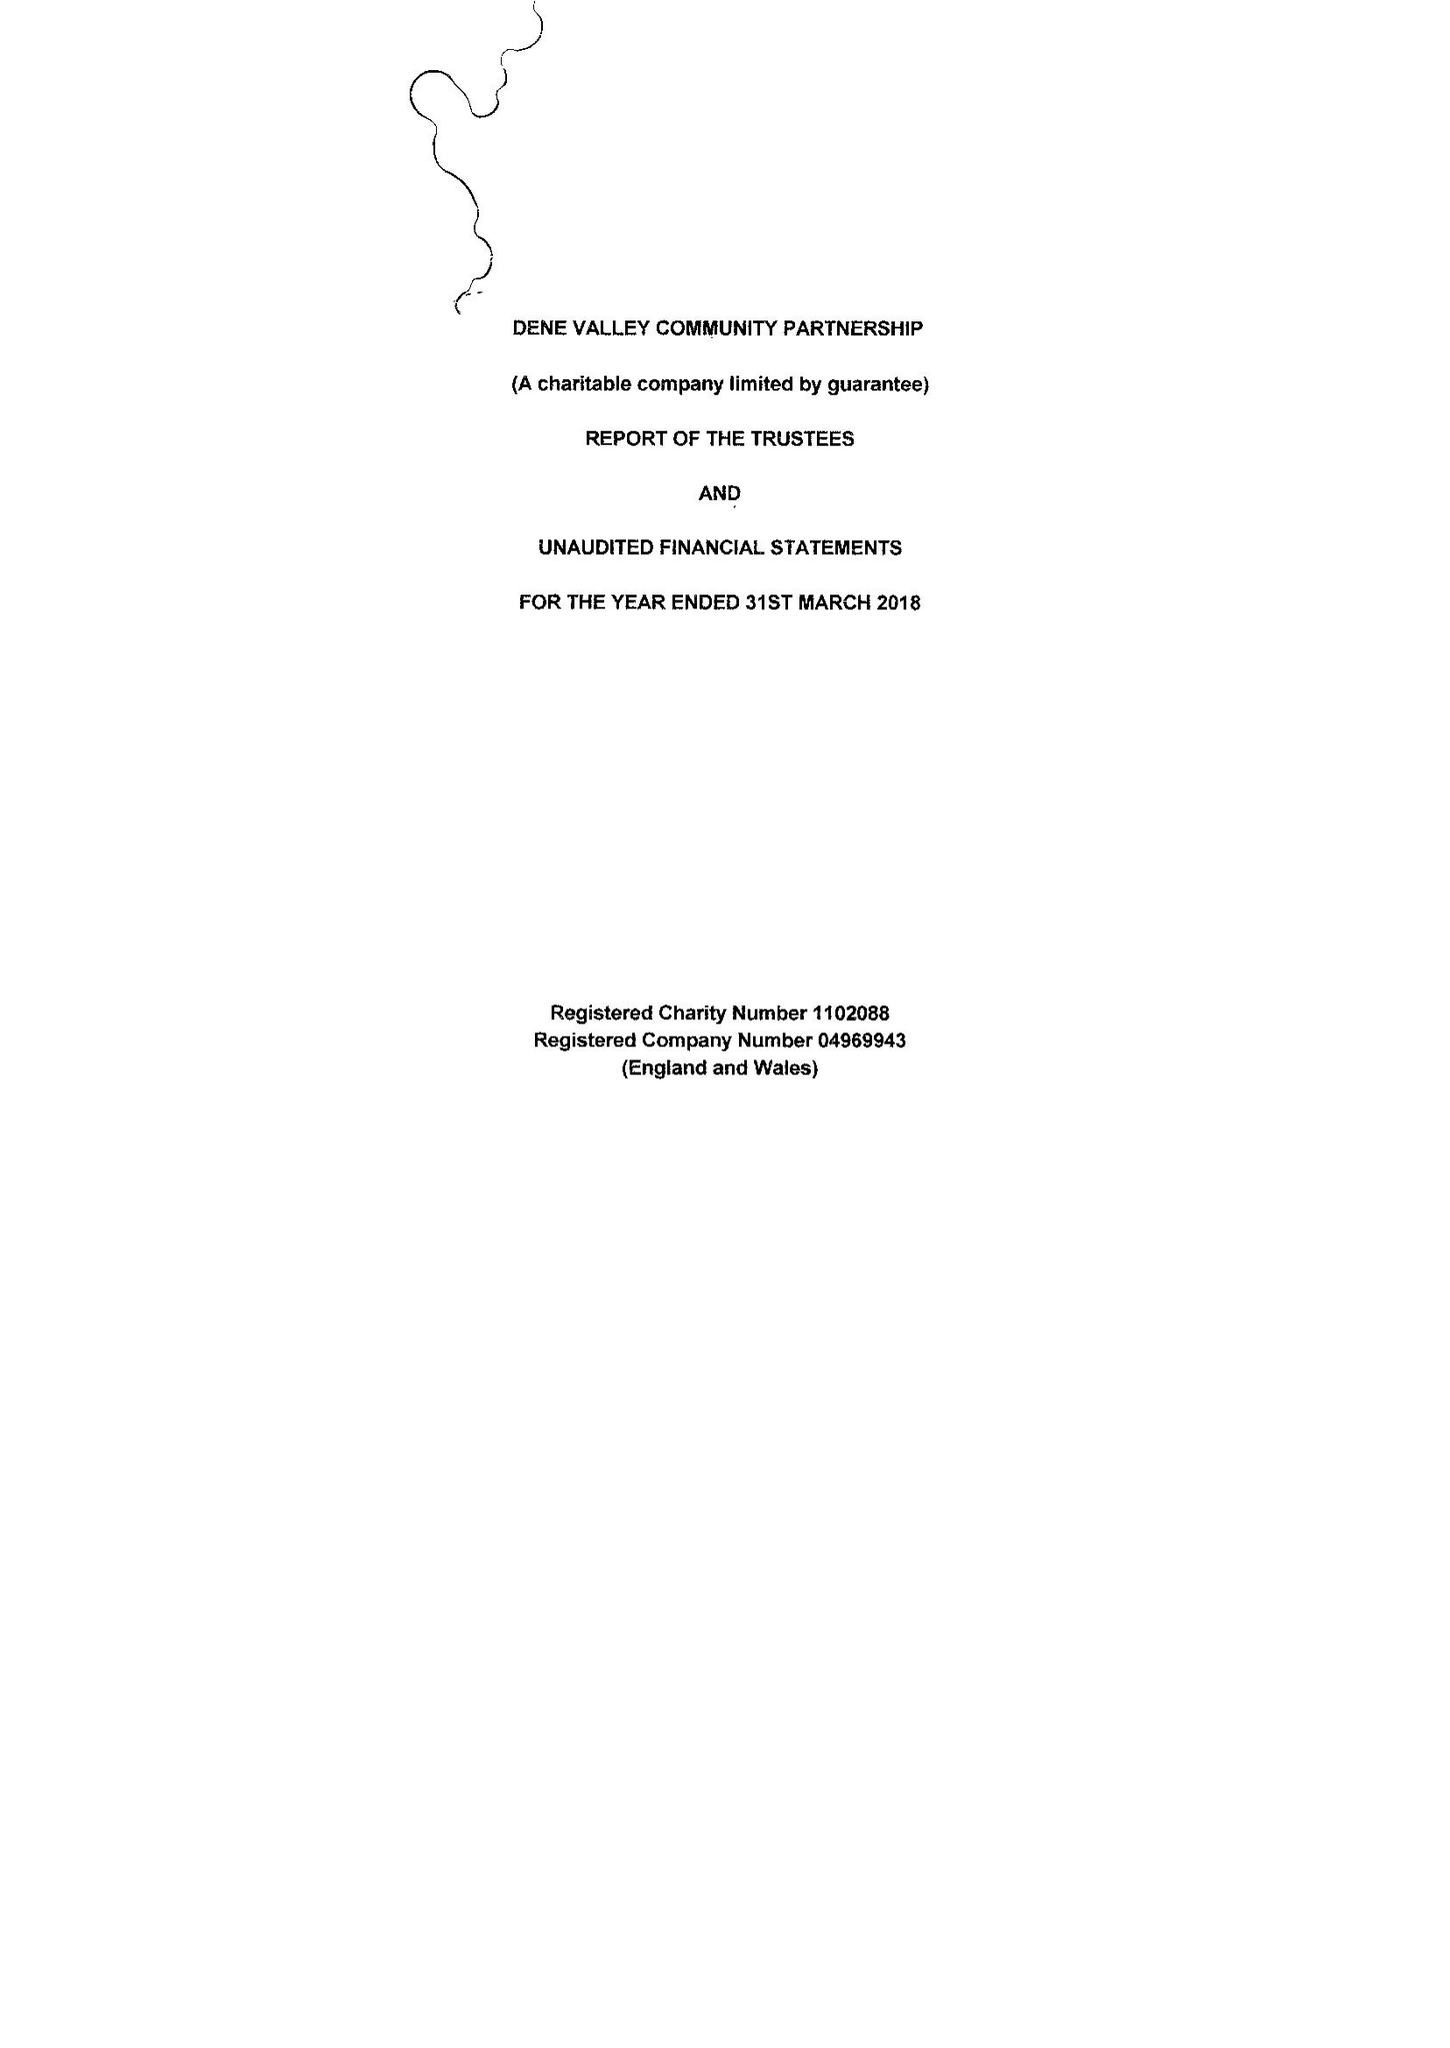What is the value for the address__street_line?
Answer the question using a single word or phrase. HIGH STREET 